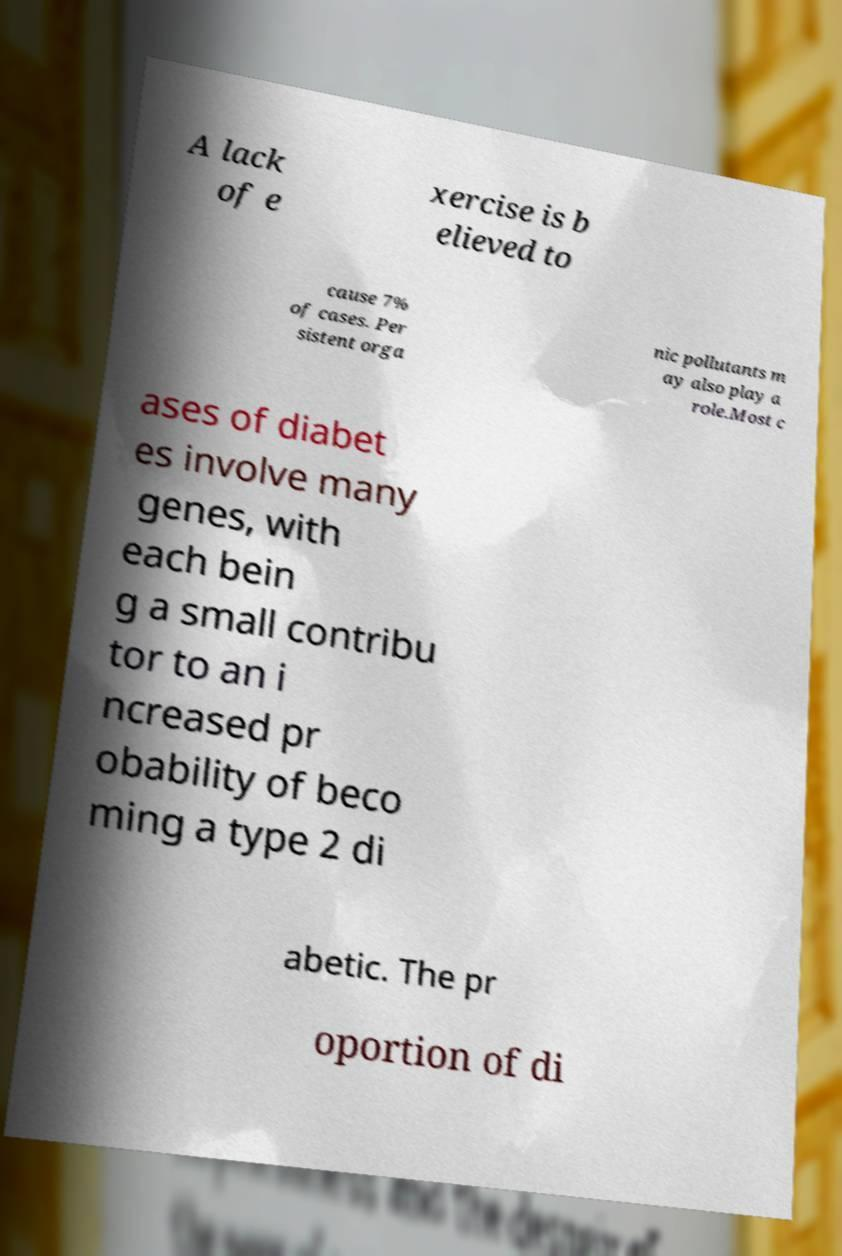Could you assist in decoding the text presented in this image and type it out clearly? A lack of e xercise is b elieved to cause 7% of cases. Per sistent orga nic pollutants m ay also play a role.Most c ases of diabet es involve many genes, with each bein g a small contribu tor to an i ncreased pr obability of beco ming a type 2 di abetic. The pr oportion of di 